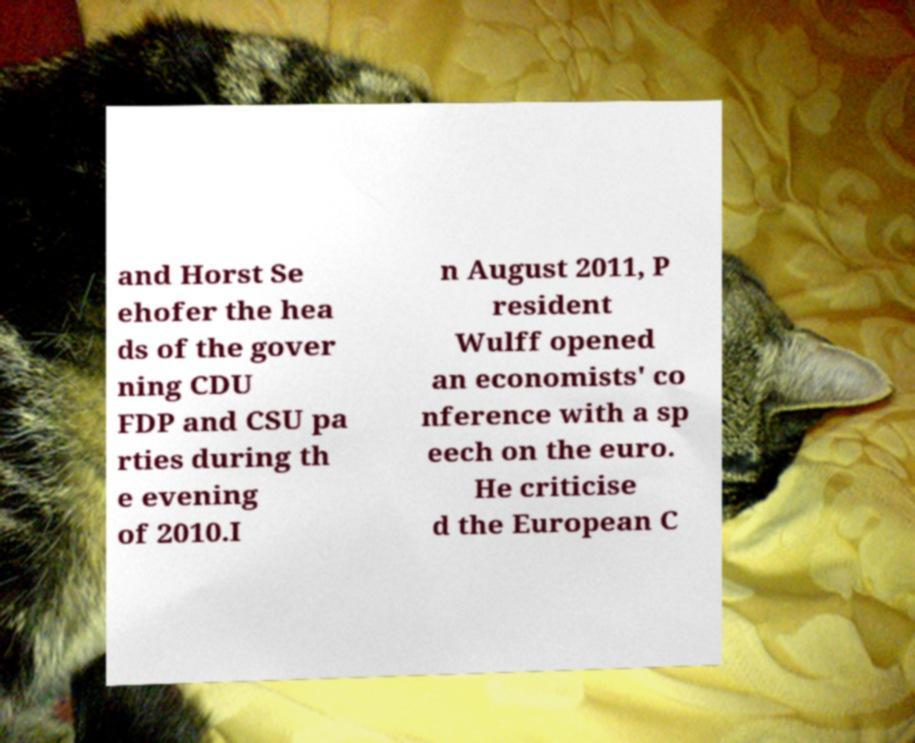Please identify and transcribe the text found in this image. and Horst Se ehofer the hea ds of the gover ning CDU FDP and CSU pa rties during th e evening of 2010.I n August 2011, P resident Wulff opened an economists' co nference with a sp eech on the euro. He criticise d the European C 